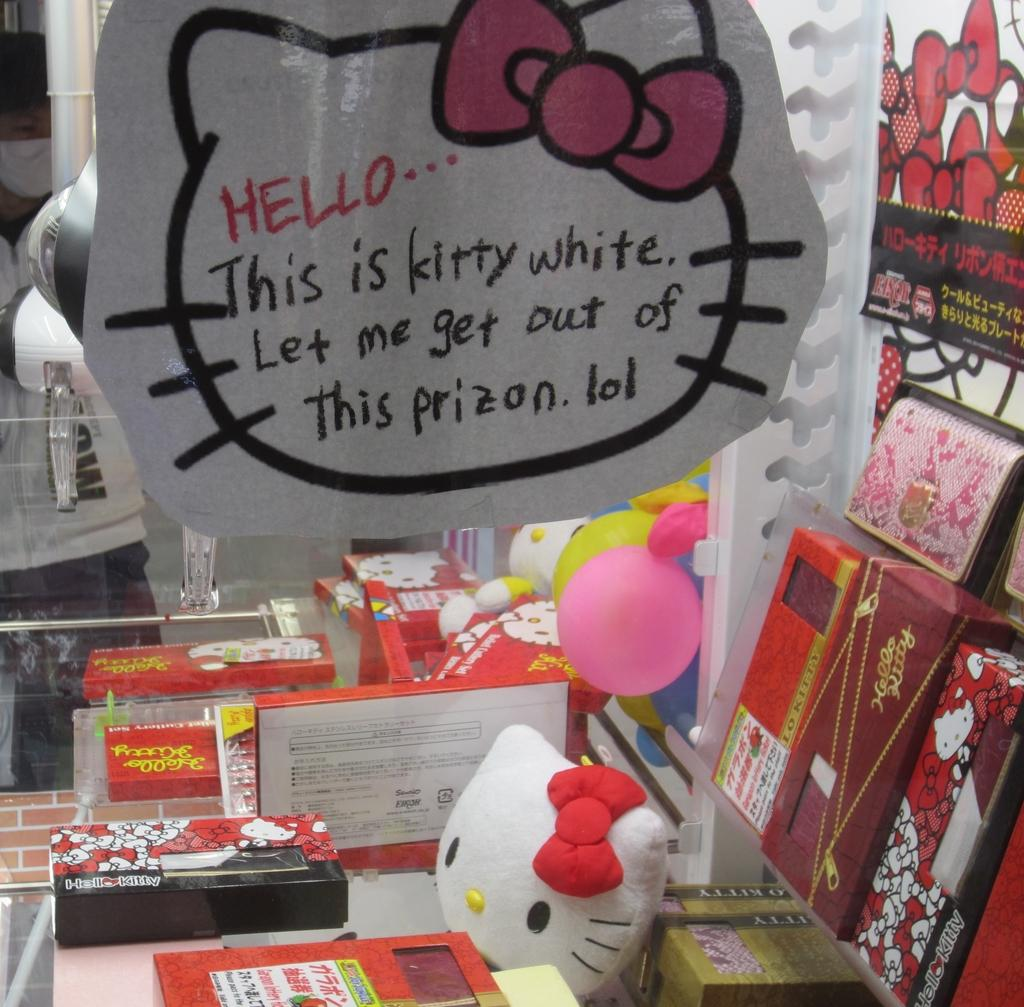<image>
Share a concise interpretation of the image provided. An outline of hello Kittys head asks for help getting out of prison. 